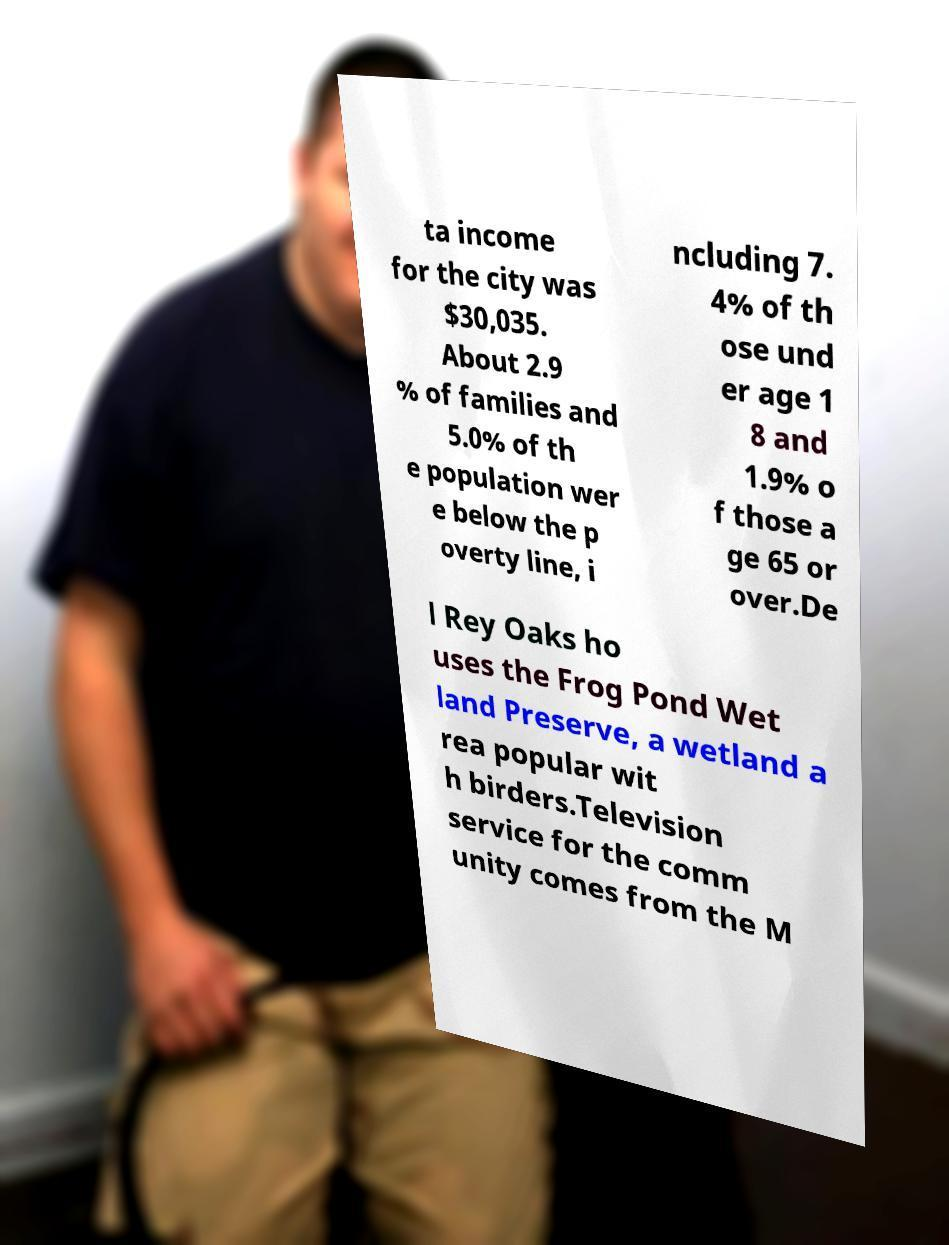Please identify and transcribe the text found in this image. ta income for the city was $30,035. About 2.9 % of families and 5.0% of th e population wer e below the p overty line, i ncluding 7. 4% of th ose und er age 1 8 and 1.9% o f those a ge 65 or over.De l Rey Oaks ho uses the Frog Pond Wet land Preserve, a wetland a rea popular wit h birders.Television service for the comm unity comes from the M 